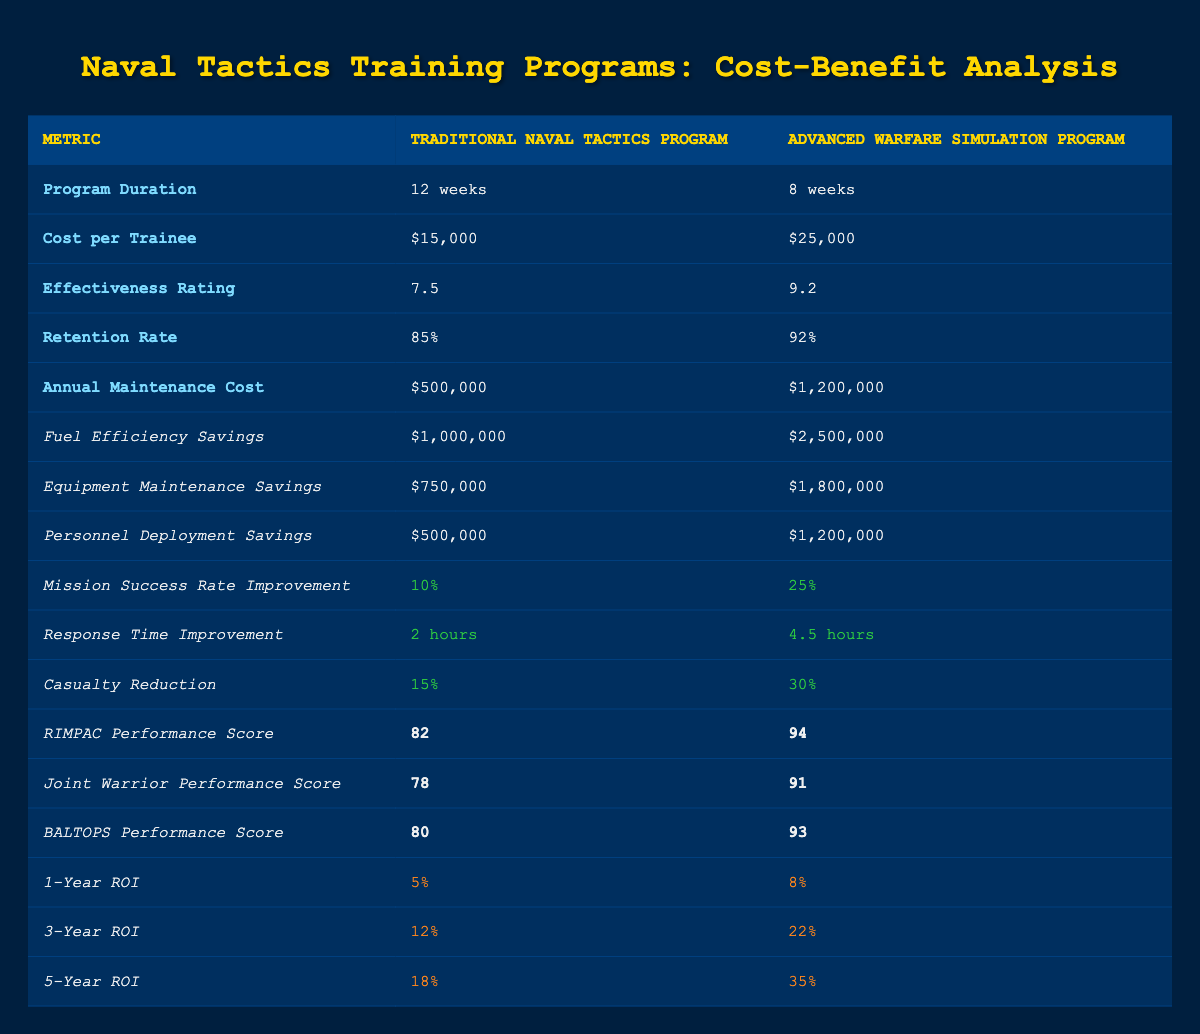What is the cost per trainee for the Advanced Warfare Simulation Program? The table specifies the cost per trainee for the Advanced Warfare Simulation Program as $25,000. This information is directly listed under the relevant column.
Answer: $25,000 How much higher is the effectiveness rating of the Advanced Warfare Simulation Program compared to the Traditional Naval Tactics Program? The effectiveness rating of the Advanced Warfare Simulation Program is 9.2, while the Traditional Naval Tactics Program has a rating of 7.5. Calculating the difference: 9.2 - 7.5 = 1.7.
Answer: 1.7 Is the retention rate for the Advanced Warfare Simulation Program higher than that of the Traditional Naval Tactics Program? The table shows the retention rate for the Advanced Warfare Simulation Program as 92% and for the Traditional Naval Tactics Program as 85%. Since 92% is greater than 85%, the answer is yes.
Answer: Yes What is the total annual maintenance cost for both training programs combined? The annual maintenance costs for the Traditional Naval Tactics Program and the Advanced Warfare Simulation Program are $500,000 and $1,200,000, respectively. To find the total, add these amounts: $500,000 + $1,200,000 = $1,700,000.
Answer: $1,700,000 In which naval exercise did the Advanced Warfare Simulation Program achieve the highest performance score? Among the naval exercises listed, the Advanced Warfare Simulation Program received a performance score of 94 in RIMPAC, which is the highest score noted in the table.
Answer: RIMPAC What is the percentage improvement in the mission success rate for both programs, and which program shows greater improvement? The Traditional Naval Tactics Program shows a 10% improvement, while the Advanced Warfare Simulation Program shows a 25% improvement. Thus, the Advanced Warfare Simulation Program has a greater improvement.
Answer: Advanced Warfare Simulation Program Based on the 5-Year ROI, which program provides a better return on investment? The table indicates a 5-Year ROI of 18% for the Traditional Naval Tactics Program and 35% for the Advanced Warfare Simulation Program. Since 35% is greater than 18%, the Advanced Warfare Simulation Program provides a better return on investment.
Answer: Advanced Warfare Simulation Program What is the average casualty reduction improvement for both programs? The casualty reduction improvement is 15% for the Traditional Naval Tactics Program and 30% for the Advanced Warfare Simulation Program. To find the average, add both percentages: 15% + 30% = 45%. Then, divide by 2: 45% / 2 = 22.5%.
Answer: 22.5% 